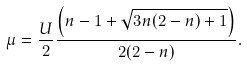Convert formula to latex. <formula><loc_0><loc_0><loc_500><loc_500>\mu = \frac { U } { 2 } \frac { \left ( n - 1 + \sqrt { 3 n ( 2 - n ) + 1 } \right ) } { 2 ( 2 - n ) } .</formula> 